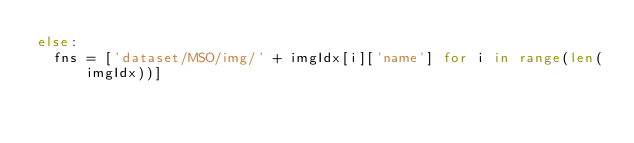Convert code to text. <code><loc_0><loc_0><loc_500><loc_500><_Python_>else:
  fns = ['dataset/MSO/img/' + imgIdx[i]['name'] for i in range(len(imgIdx))]</code> 